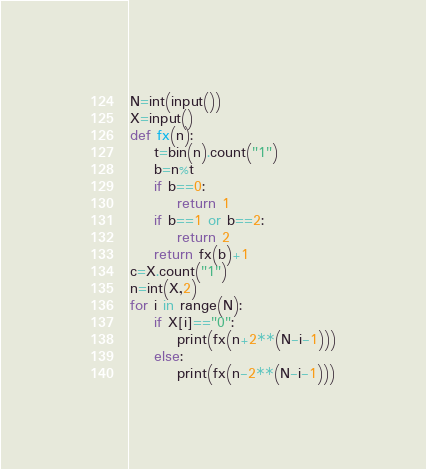<code> <loc_0><loc_0><loc_500><loc_500><_Python_>N=int(input())
X=input()
def fx(n):
    t=bin(n).count("1")
    b=n%t
    if b==0:
        return 1
    if b==1 or b==2:
        return 2
    return fx(b)+1
c=X.count("1")
n=int(X,2)
for i in range(N):
    if X[i]=="0":
        print(fx(n+2**(N-i-1)))
    else:
        print(fx(n-2**(N-i-1)))</code> 